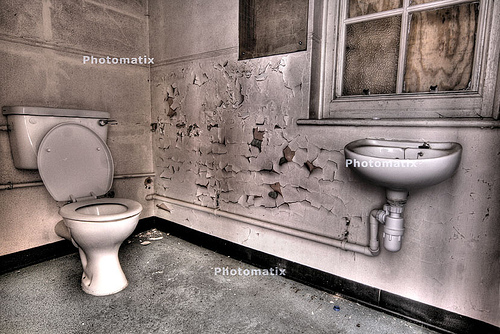Please extract the text content from this image. photomatix PHotomatix Photomatix 